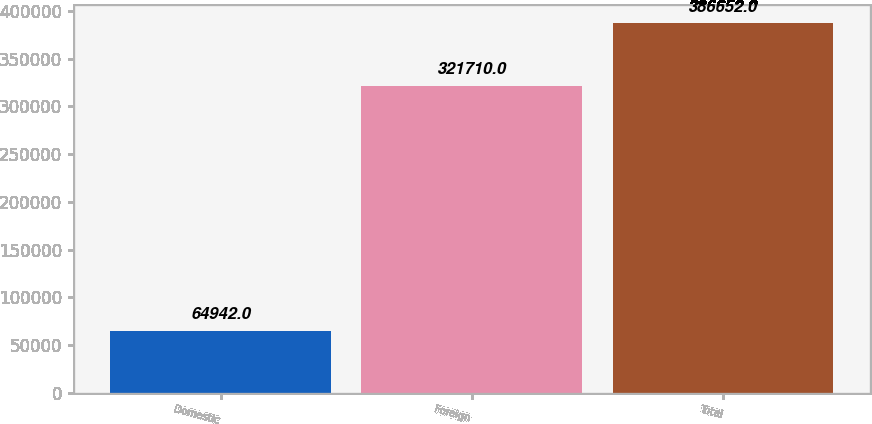Convert chart. <chart><loc_0><loc_0><loc_500><loc_500><bar_chart><fcel>Domestic<fcel>Foreign<fcel>Total<nl><fcel>64942<fcel>321710<fcel>386652<nl></chart> 